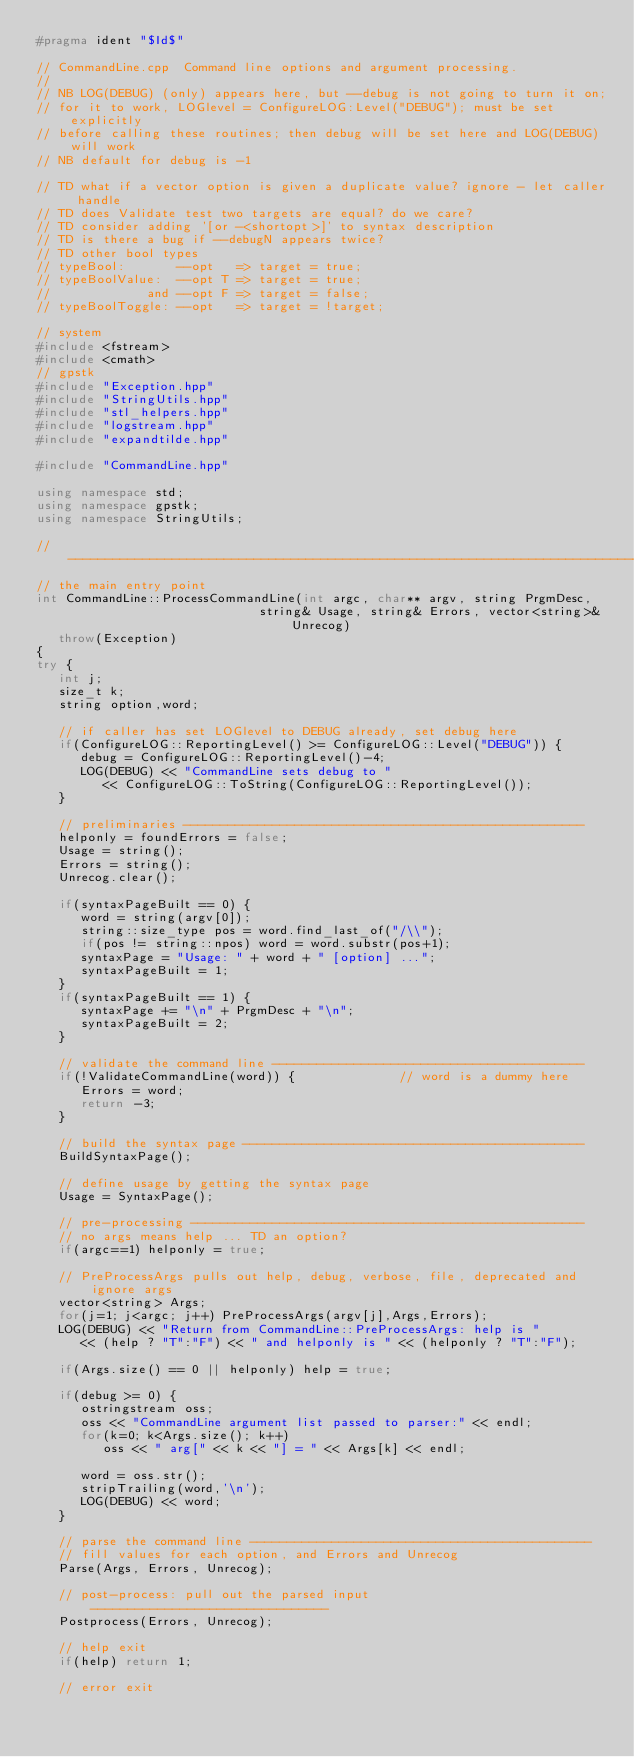<code> <loc_0><loc_0><loc_500><loc_500><_C++_>#pragma ident "$Id$"

// CommandLine.cpp  Command line options and argument processing.
//
// NB LOG(DEBUG) (only) appears here, but --debug is not going to turn it on;
// for it to work, LOGlevel = ConfigureLOG:Level("DEBUG"); must be set explicitly
// before calling these routines; then debug will be set here and LOG(DEBUG) will work
// NB default for debug is -1

// TD what if a vector option is given a duplicate value? ignore - let caller handle
// TD does Validate test two targets are equal? do we care?
// TD consider adding '[or -<shortopt>]' to syntax description
// TD is there a bug if --debugN appears twice?
// TD other bool types
// typeBool:       --opt   => target = true;
// typeBoolValue:  --opt T => target = true;
//             and --opt F => target = false;
// typeBoolToggle: --opt   => target = !target;

// system
#include <fstream>
#include <cmath>
// gpstk
#include "Exception.hpp"
#include "StringUtils.hpp"
#include "stl_helpers.hpp"
#include "logstream.hpp"
#include "expandtilde.hpp"

#include "CommandLine.hpp"

using namespace std;
using namespace gpstk;
using namespace StringUtils;

// -----------------------------------------------------------------------------------
// the main entry point
int CommandLine::ProcessCommandLine(int argc, char** argv, string PrgmDesc,
                              string& Usage, string& Errors, vector<string>& Unrecog)
   throw(Exception)
{
try {
   int j;
   size_t k;
   string option,word;

   // if caller has set LOGlevel to DEBUG already, set debug here
   if(ConfigureLOG::ReportingLevel() >= ConfigureLOG::Level("DEBUG")) {
      debug = ConfigureLOG::ReportingLevel()-4;
      LOG(DEBUG) << "CommandLine sets debug to "
         << ConfigureLOG::ToString(ConfigureLOG::ReportingLevel());
   }

   // preliminaries ------------------------------------------------------
   helponly = foundErrors = false;
   Usage = string();
   Errors = string();
   Unrecog.clear();

   if(syntaxPageBuilt == 0) {
      word = string(argv[0]);
      string::size_type pos = word.find_last_of("/\\");
      if(pos != string::npos) word = word.substr(pos+1);
      syntaxPage = "Usage: " + word + " [option] ...";
      syntaxPageBuilt = 1;
   }
   if(syntaxPageBuilt == 1) {
      syntaxPage += "\n" + PrgmDesc + "\n";
      syntaxPageBuilt = 2;
   }

   // validate the command line ------------------------------------------
   if(!ValidateCommandLine(word)) {              // word is a dummy here
      Errors = word;
      return -3;
   }

   // build the syntax page ----------------------------------------------
   BuildSyntaxPage();

   // define usage by getting the syntax page
   Usage = SyntaxPage();

   // pre-processing -----------------------------------------------------
   // no args means help ... TD an option?
   if(argc==1) helponly = true;

   // PreProcessArgs pulls out help, debug, verbose, file, deprecated and ignore args
   vector<string> Args;
   for(j=1; j<argc; j++) PreProcessArgs(argv[j],Args,Errors);
   LOG(DEBUG) << "Return from CommandLine::PreProcessArgs: help is "
      << (help ? "T":"F") << " and helponly is " << (helponly ? "T":"F");

   if(Args.size() == 0 || helponly) help = true;

   if(debug >= 0) {
      ostringstream oss;
      oss << "CommandLine argument list passed to parser:" << endl;
      for(k=0; k<Args.size(); k++)
         oss << " arg[" << k << "] = " << Args[k] << endl;

      word = oss.str();
      stripTrailing(word,'\n');
      LOG(DEBUG) << word;
   }

   // parse the command line ----------------------------------------------
   // fill values for each option, and Errors and Unrecog
   Parse(Args, Errors, Unrecog);

   // post-process: pull out the parsed input --------------------------------
   Postprocess(Errors, Unrecog);

   // help exit
   if(help) return 1;

   // error exit</code> 